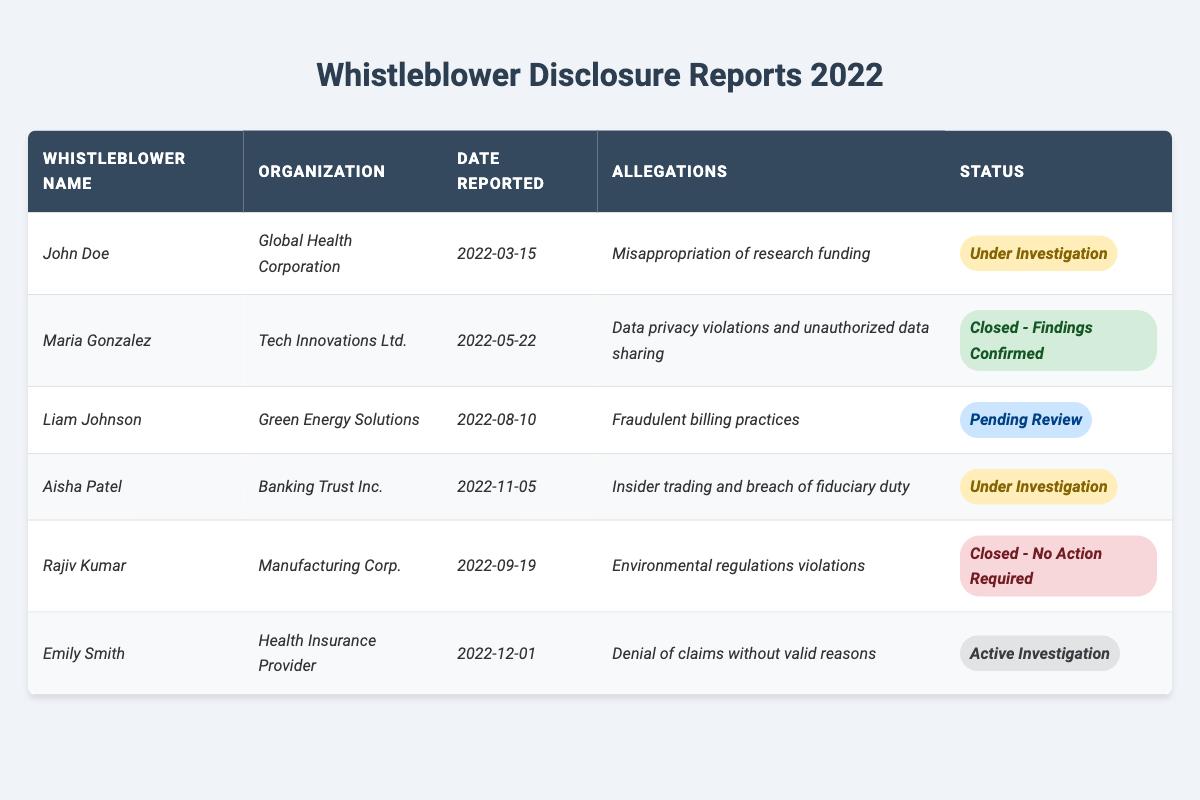What are the allegations reported by Maria Gonzalez? Maria Gonzalez reported allegations of data privacy violations and unauthorized data sharing, as stated in the table under her entry.
Answer: Data privacy violations and unauthorized data sharing How many reports have the status "Under Investigation"? There are 2 entries with the status "Under Investigation": one from John Doe and one from Aisha Patel, which can be counted from the corresponding entries in the table.
Answer: 2 Which organization reported allegations of environmental regulations violations? The organization that reported allegations of environmental regulations violations is Manufacturing Corp., which is directly referenced in the table.
Answer: Manufacturing Corp What is the earliest date reported for any whistleblower disclosure? The earliest date reported is March 15, 2022, as indicated by John Doe's entry in the table.
Answer: March 15, 2022 How many total whistleblowers reported allegations related to financial misconduct (which includes misappropriation of funding and insider trading)? Two whistleblowers reported allegations related to financial misconduct: John Doe (misappropriation of research funding) and Aisha Patel (insider trading). So, the total is 2.
Answer: 2 Is the report by Liam Johnson still under investigation? No, it is currently listed as "Pending Review," which is distinct from "Under Investigation," as can be seen in his entry in the table.
Answer: No What is the status of the report made by Emily Smith? Emily Smith's report is under the status "Active Investigation," as specified in her row in the table.
Answer: Active Investigation Are there more reports that have been closed than those that are still under investigation? Yes, there are 3 reports that have been closed (Maria Gonzalez, Rajiv Kumar) compared to 2 under investigation, which shows that closed reports outnumber those under investigation.
Answer: Yes Which whistleblower disclosed their report last in 2022? The last report disclosed in 2022 is from Emily Smith on December 1, 2022, as indicated in the last row of the table.
Answer: Emily Smith What is the most common current status among the reports? The most common current status is "Under Investigation," which applies to 2 different reports as per the data in the table.
Answer: Under Investigation 